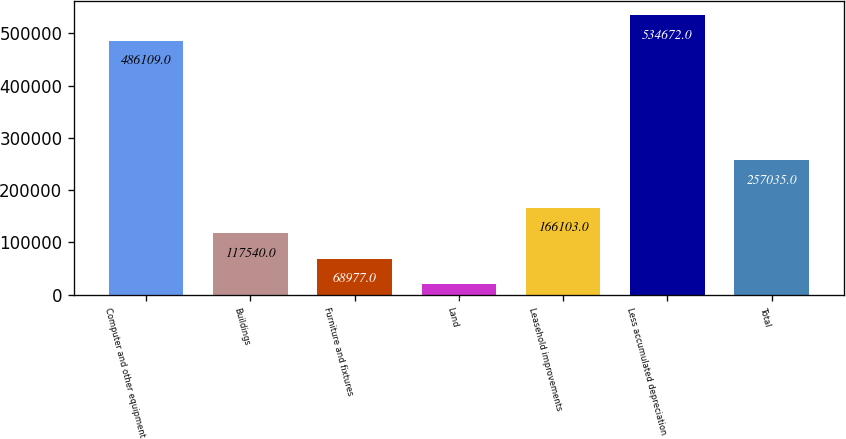Convert chart. <chart><loc_0><loc_0><loc_500><loc_500><bar_chart><fcel>Computer and other equipment<fcel>Buildings<fcel>Furniture and fixtures<fcel>Land<fcel>Leasehold improvements<fcel>Less accumulated depreciation<fcel>Total<nl><fcel>486109<fcel>117540<fcel>68977<fcel>20414<fcel>166103<fcel>534672<fcel>257035<nl></chart> 